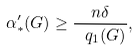Convert formula to latex. <formula><loc_0><loc_0><loc_500><loc_500>\alpha ^ { \prime } _ { * } ( G ) \geq \frac { n \delta } { \ q _ { 1 } ( G ) } ,</formula> 